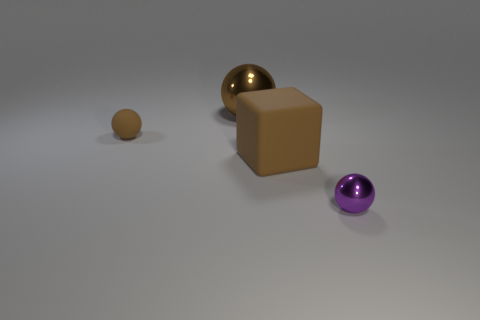Subtract 1 balls. How many balls are left? 2 Add 4 big purple objects. How many objects exist? 8 Subtract all balls. How many objects are left? 1 Subtract 0 cyan cubes. How many objects are left? 4 Subtract all brown cylinders. Subtract all metal balls. How many objects are left? 2 Add 1 small metal spheres. How many small metal spheres are left? 2 Add 1 brown matte objects. How many brown matte objects exist? 3 